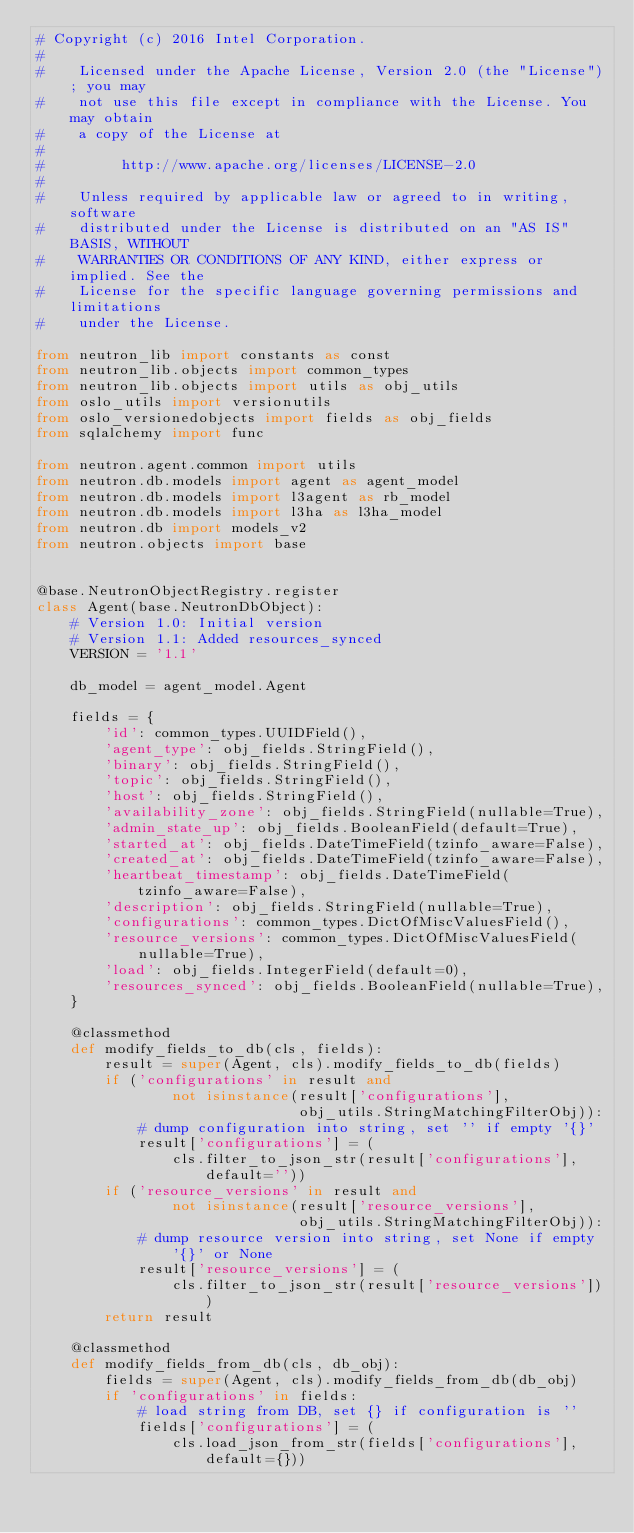<code> <loc_0><loc_0><loc_500><loc_500><_Python_># Copyright (c) 2016 Intel Corporation.
#
#    Licensed under the Apache License, Version 2.0 (the "License"); you may
#    not use this file except in compliance with the License. You may obtain
#    a copy of the License at
#
#         http://www.apache.org/licenses/LICENSE-2.0
#
#    Unless required by applicable law or agreed to in writing, software
#    distributed under the License is distributed on an "AS IS" BASIS, WITHOUT
#    WARRANTIES OR CONDITIONS OF ANY KIND, either express or implied. See the
#    License for the specific language governing permissions and limitations
#    under the License.

from neutron_lib import constants as const
from neutron_lib.objects import common_types
from neutron_lib.objects import utils as obj_utils
from oslo_utils import versionutils
from oslo_versionedobjects import fields as obj_fields
from sqlalchemy import func

from neutron.agent.common import utils
from neutron.db.models import agent as agent_model
from neutron.db.models import l3agent as rb_model
from neutron.db.models import l3ha as l3ha_model
from neutron.db import models_v2
from neutron.objects import base


@base.NeutronObjectRegistry.register
class Agent(base.NeutronDbObject):
    # Version 1.0: Initial version
    # Version 1.1: Added resources_synced
    VERSION = '1.1'

    db_model = agent_model.Agent

    fields = {
        'id': common_types.UUIDField(),
        'agent_type': obj_fields.StringField(),
        'binary': obj_fields.StringField(),
        'topic': obj_fields.StringField(),
        'host': obj_fields.StringField(),
        'availability_zone': obj_fields.StringField(nullable=True),
        'admin_state_up': obj_fields.BooleanField(default=True),
        'started_at': obj_fields.DateTimeField(tzinfo_aware=False),
        'created_at': obj_fields.DateTimeField(tzinfo_aware=False),
        'heartbeat_timestamp': obj_fields.DateTimeField(tzinfo_aware=False),
        'description': obj_fields.StringField(nullable=True),
        'configurations': common_types.DictOfMiscValuesField(),
        'resource_versions': common_types.DictOfMiscValuesField(nullable=True),
        'load': obj_fields.IntegerField(default=0),
        'resources_synced': obj_fields.BooleanField(nullable=True),
    }

    @classmethod
    def modify_fields_to_db(cls, fields):
        result = super(Agent, cls).modify_fields_to_db(fields)
        if ('configurations' in result and
                not isinstance(result['configurations'],
                               obj_utils.StringMatchingFilterObj)):
            # dump configuration into string, set '' if empty '{}'
            result['configurations'] = (
                cls.filter_to_json_str(result['configurations'], default=''))
        if ('resource_versions' in result and
                not isinstance(result['resource_versions'],
                               obj_utils.StringMatchingFilterObj)):
            # dump resource version into string, set None if empty '{}' or None
            result['resource_versions'] = (
                cls.filter_to_json_str(result['resource_versions']))
        return result

    @classmethod
    def modify_fields_from_db(cls, db_obj):
        fields = super(Agent, cls).modify_fields_from_db(db_obj)
        if 'configurations' in fields:
            # load string from DB, set {} if configuration is ''
            fields['configurations'] = (
                cls.load_json_from_str(fields['configurations'], default={}))</code> 